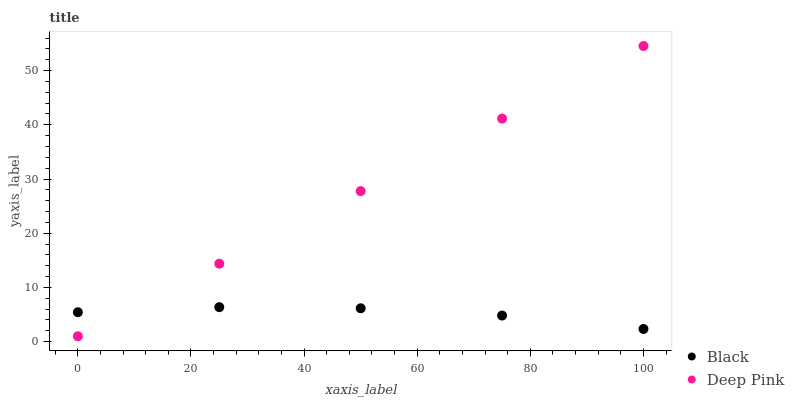Does Black have the minimum area under the curve?
Answer yes or no. Yes. Does Deep Pink have the maximum area under the curve?
Answer yes or no. Yes. Does Black have the maximum area under the curve?
Answer yes or no. No. Is Deep Pink the smoothest?
Answer yes or no. Yes. Is Black the roughest?
Answer yes or no. Yes. Is Black the smoothest?
Answer yes or no. No. Does Deep Pink have the lowest value?
Answer yes or no. Yes. Does Black have the lowest value?
Answer yes or no. No. Does Deep Pink have the highest value?
Answer yes or no. Yes. Does Black have the highest value?
Answer yes or no. No. Does Black intersect Deep Pink?
Answer yes or no. Yes. Is Black less than Deep Pink?
Answer yes or no. No. Is Black greater than Deep Pink?
Answer yes or no. No. 